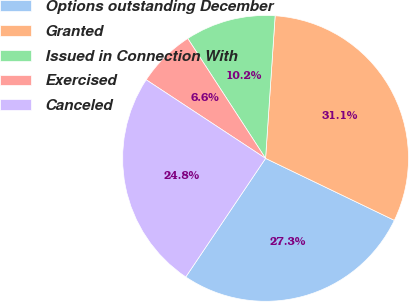<chart> <loc_0><loc_0><loc_500><loc_500><pie_chart><fcel>Options outstanding December<fcel>Granted<fcel>Issued in Connection With<fcel>Exercised<fcel>Canceled<nl><fcel>27.29%<fcel>31.07%<fcel>10.23%<fcel>6.57%<fcel>24.84%<nl></chart> 